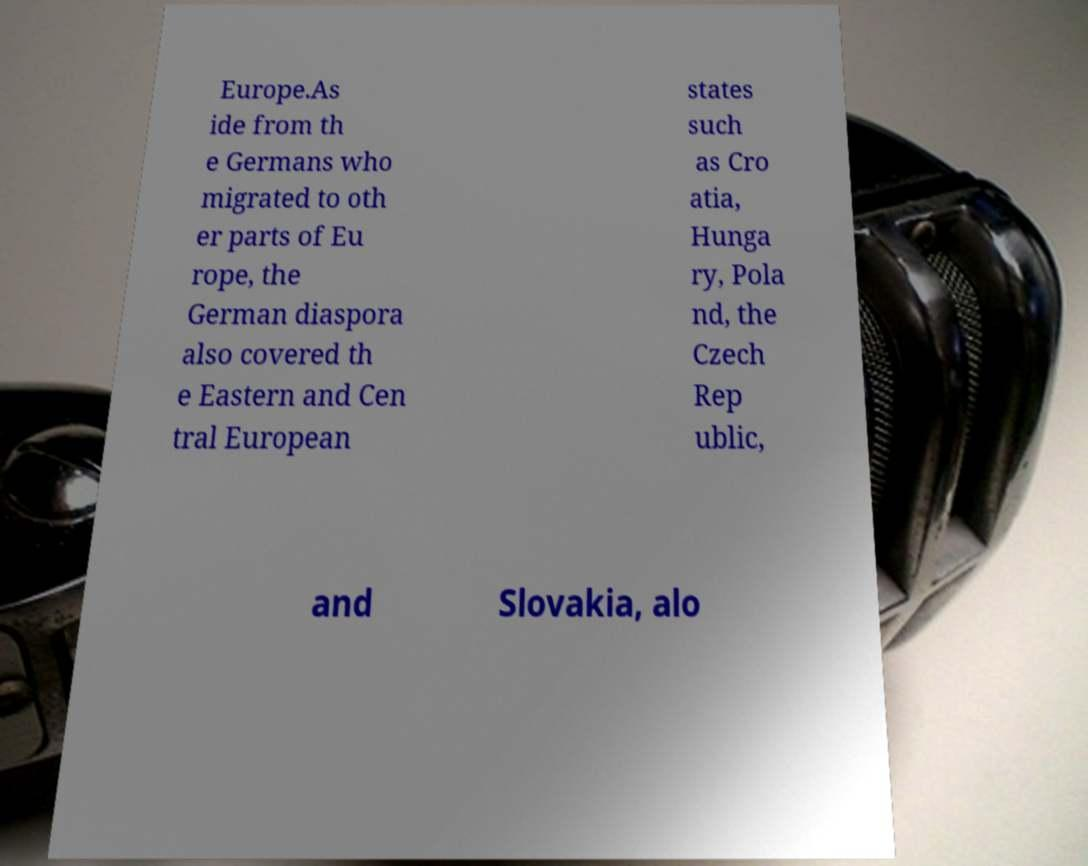Could you extract and type out the text from this image? Europe.As ide from th e Germans who migrated to oth er parts of Eu rope, the German diaspora also covered th e Eastern and Cen tral European states such as Cro atia, Hunga ry, Pola nd, the Czech Rep ublic, and Slovakia, alo 